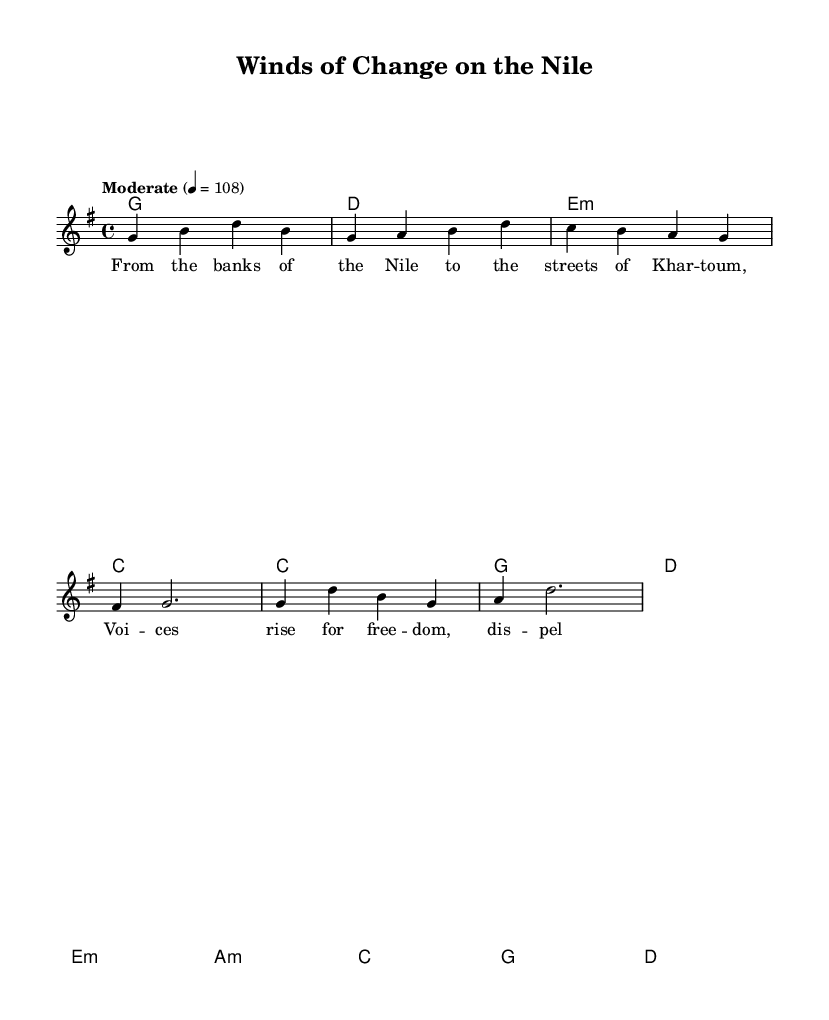What is the key signature of this music? The key signature is G major, which has one sharp (F#).
Answer: G major What is the time signature of this piece? The time signature is 4/4, indicating four beats per measure.
Answer: 4/4 What is the tempo marking given in the score? The tempo marking states "Moderate" with a metronome marking of 108 beats per minute.
Answer: 108 What chord progression is used in the verse? The chord progression in the verse is G, D, E minor, C, as indicated in the chordmode section.
Answer: G, D, E minor, C How many measures are there in the chorus? The chorus has four measures, reflecting the structure shown in the chord progression.
Answer: 4 What is the melodic highest note in the melody? The highest note in the melody is D, which is found at the beginning.
Answer: D What type of instrument is suggested by the presence of the harmonica riff? The inclusion of a harmonica riff suggests the use of a harmonica as a lead instrument in this country rock piece.
Answer: Harmonica 